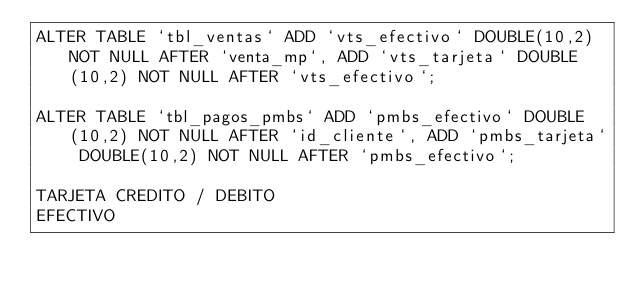<code> <loc_0><loc_0><loc_500><loc_500><_SQL_>ALTER TABLE `tbl_ventas` ADD `vts_efectivo` DOUBLE(10,2) NOT NULL AFTER `venta_mp`, ADD `vts_tarjeta` DOUBLE(10,2) NOT NULL AFTER `vts_efectivo`;

ALTER TABLE `tbl_pagos_pmbs` ADD `pmbs_efectivo` DOUBLE(10,2) NOT NULL AFTER `id_cliente`, ADD `pmbs_tarjeta` DOUBLE(10,2) NOT NULL AFTER `pmbs_efectivo`;

TARJETA CREDITO / DEBITO
EFECTIVO</code> 